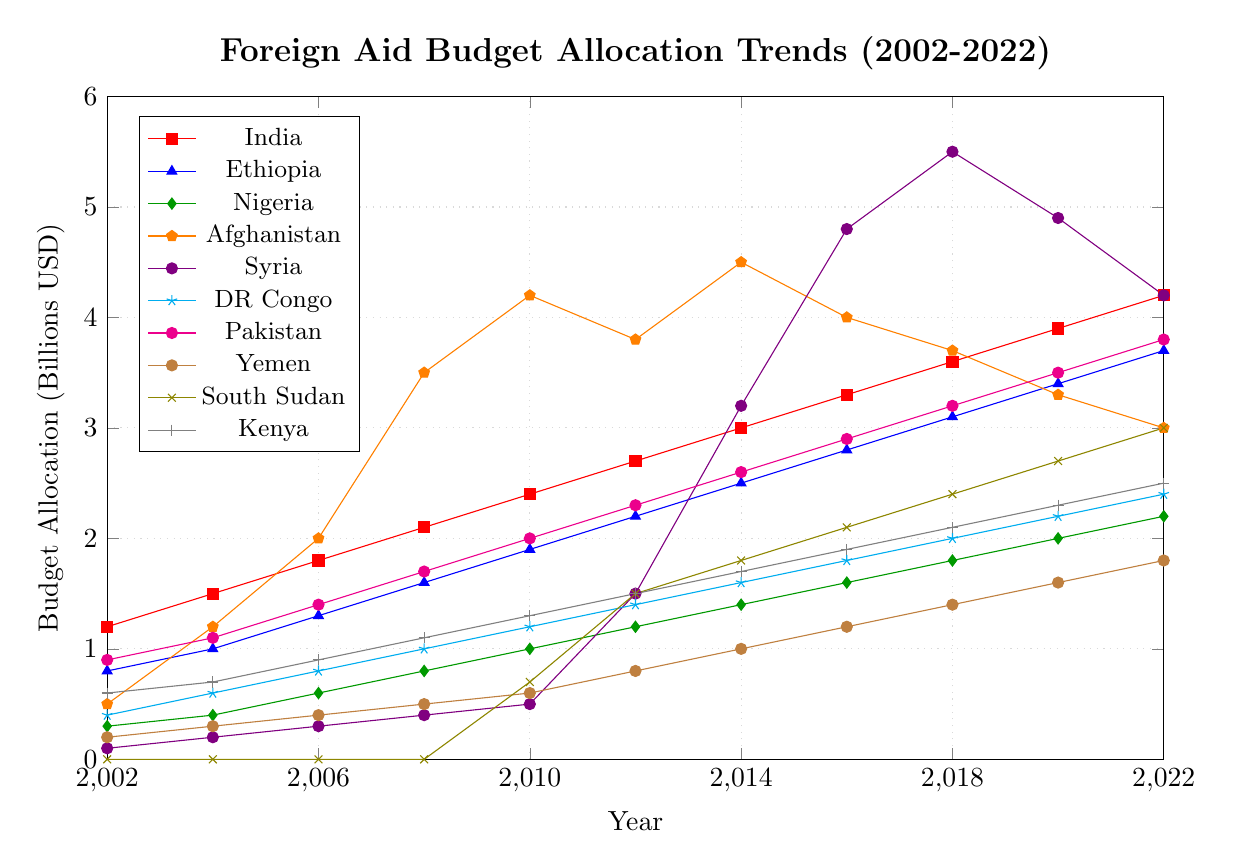Which country saw the largest increase in foreign aid from 2002 to 2022? The largest increase can be observed by calculating the difference between the 2022 and 2002 budget allocation for each country. For India, it's 4.2 - 1.2 = 3.0; for Ethiopia, it's 3.7 - 0.8 = 2.9; for Nigeria, it's 2.2 - 0.3 = 1.9; for Afghanistan, it's 3.0 - 0.5 = 2.5; for Syria, it's 4.2 - 0.1 = 4.1; for DR Congo, it's 2.4 - 0.4 = 2.0; for Pakistan, it's 3.8 - 0.9 = 2.9; for Yemen, it's 1.8 - 0.2 = 1.6; for South Sudan, it's 3.0 - 0.0 = 3.0; for Kenya, it's 2.5 - 0.6 = 1.9. Therefore, Syria saw the largest increase.
Answer: Syria Which country had the highest budget allocation in 2022? By looking at the 2022 data points, we can see that India had 4.2, Ethiopia 3.7, Nigeria 2.2, Afghanistan 3.0, Syria 4.2, DR Congo 2.4, Pakistan 3.8, Yemen 1.8, South Sudan 3.0, and Kenya 2.5. Both India and Syria had the highest allocation in 2022 with 4.2 billion USD each.
Answer: India and Syria Which country showed a decline in foreign aid allocation after reaching its peak within the two-decade period? By observing the trends, Afghanistan peaked at 4.5 billion USD in 2014 and then declined to 3.0 billion USD in 2022; Syria peaked at 5.5 billion USD in 2018 and then declined to 4.2 billion USD in 2022.
Answer: Afghanistan and Syria Between 2016 and 2020, which country's foreign aid allocation increased the most? To determine the increase, we subtract the 2016 values from the 2020 values: India 3.9 - 3.3 = 0.6, Ethiopia 3.4 - 2.8 = 0.6, Nigeria 2.0 - 1.6 = 0.4, Afghanistan 3.3 - 4.0 = -0.7, Syria 4.9 - 4.8 = 0.1, DR Congo 2.2 - 1.8 = 0.4, Pakistan 3.5 - 2.9 = 0.6, Yemen 1.6 - 1.2 = 0.4, South Sudan 2.7 - 2.1 = 0.6, Kenya 2.3 - 1.9 = 0.4. Several countries increased by 0.6 billion USD.
Answer: India, Ethiopia, Pakistan, South Sudan What was the total foreign aid allocation for Nigeria over the two decades? Summing all the allocations for Nigeria over the years: 0.3 (2002) + 0.4 (2004) + 0.6 (2006) + 0.8 (2008) + 1.0 (2010) + 1.2 (2012) + 1.4 (2014) + 1.6 (2016) + 1.8 (2018) + 2.0 (2020) + 2.2 (2022) = 13.3 billion USD.
Answer: 13.3 billion USD In which year did South Sudan first receive over 1 billion USD in foreign aid? Looking at the data for South Sudan, we see that it first surpassed 1 billion USD in 2012 with an allocation of 1.5 billion USD.
Answer: 2012 Which countries had a consistently increasing foreign aid trend over the past two decades without any decline? By examining the data, India, Ethiopia, Nigeria, DR Congo, Pakistan, and Kenya all show a consistently increasing trend without any decline over the entire period from 2002 to 2022.
Answer: India, Ethiopia, Nigeria, DR Congo, Pakistan, Kenya 